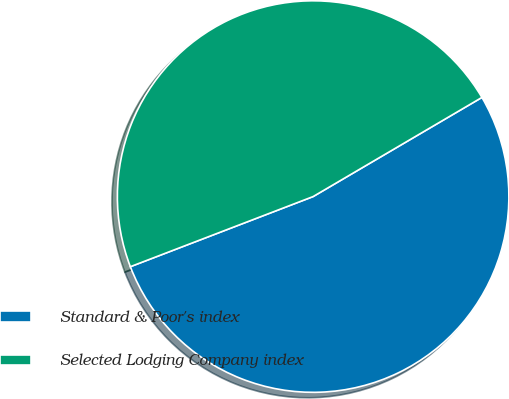Convert chart. <chart><loc_0><loc_0><loc_500><loc_500><pie_chart><fcel>Standard & Poor's index<fcel>Selected Lodging Company index<nl><fcel>52.62%<fcel>47.38%<nl></chart> 